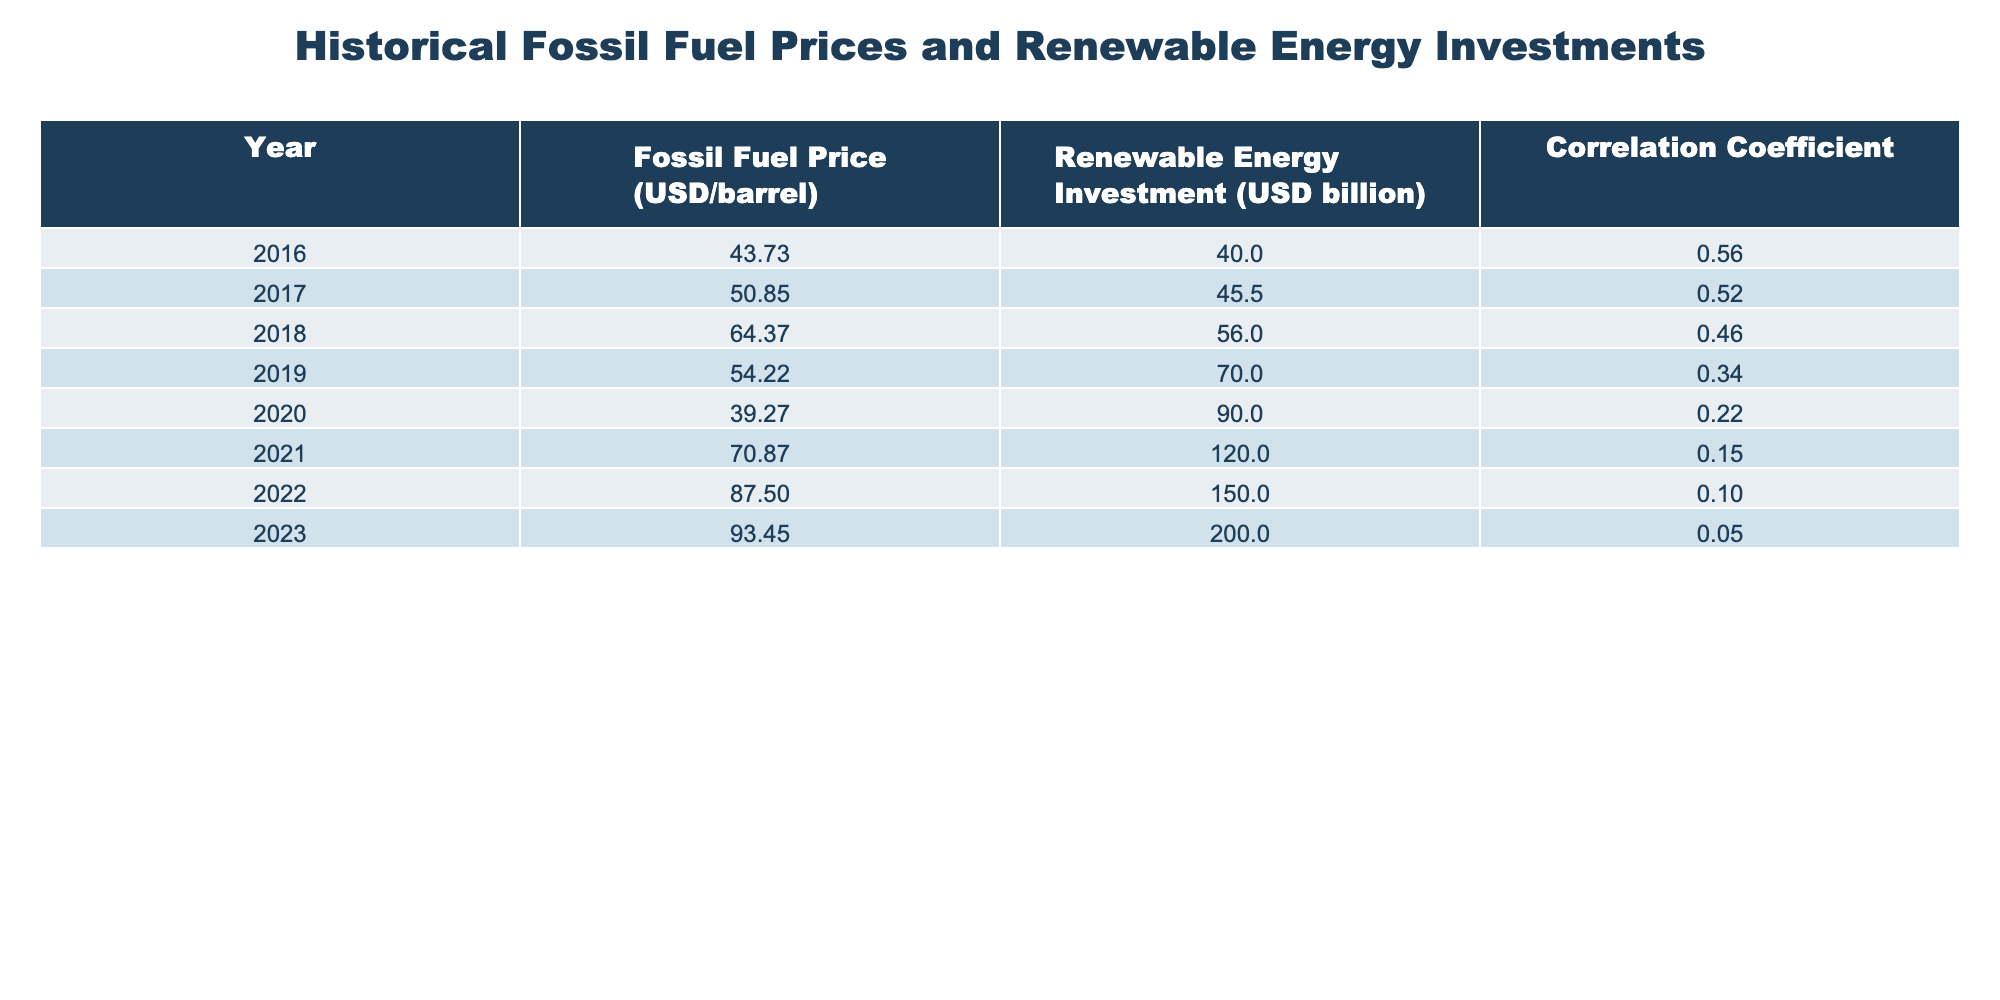What was the fossil fuel price in 2016? The table clearly indicates that the fossil fuel price for the year 2016 was 43.73 USD per barrel.
Answer: 43.73 USD/barrel What was the correlation coefficient between fossil fuel prices and renewable energy investments in 2023? According to the table, the correlation coefficient for the year 2023 is 0.05, which indicates a very weak correlation.
Answer: 0.05 How did renewable energy investments change from 2016 to 2023? In 2016, renewable energy investments were 40.0 billion USD, and by 2023, they had increased to 200.0 billion USD. This shows an increase of 160.0 billion USD over the seven-year period.
Answer: Increased by 160.0 billion USD What was the average fossil fuel price from 2016 to 2023? To find the average, sum all the fossil fuel prices: (43.73 + 50.85 + 64.37 + 54.22 + 39.27 + 70.87 + 87.50 + 93.45) = 404.26. There are 8 data points, hence the average price is 404.26 / 8 = 50.53 USD/barrel.
Answer: 50.53 USD/barrel In which year did the fossil fuel price show the highest value? The table shows that the highest fossil fuel price was in 2023 at 93.45 USD per barrel.
Answer: 2023 Was the correlation coefficient consistently decreasing over the years? By observing the correlation coefficients from 2016 to 2023, they are: 0.56, 0.52, 0.46, 0.34, 0.22, 0.15, 0.10, and 0.05. This indicates a consistent decrease over the years.
Answer: Yes How much did renewable energy investments increase from 2020 to 2022? Renewable energy investments in 2020 were 90.0 billion USD and in 2022 were 150.0 billion USD. The increase is calculated as 150.0 - 90.0 = 60.0 billion USD.
Answer: 60.0 billion USD Which year had the lowest correlation between fossil fuel prices and renewable energy investments? The year with the lowest correlation is 2023, as it has the correlation coefficient of 0.05, the smallest value in the table.
Answer: 2023 What was the difference in renewable energy investments between 2016 and 2021? Renewable energy investments in 2016 were 40.0 billion USD and in 2021 were 120.0 billion USD. The difference is 120.0 - 40.0 = 80.0 billion USD.
Answer: 80.0 billion USD 